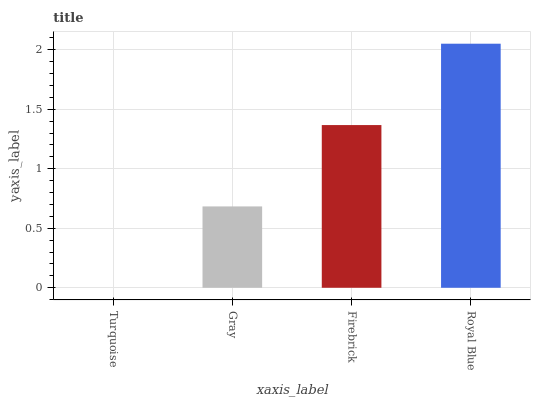Is Turquoise the minimum?
Answer yes or no. Yes. Is Royal Blue the maximum?
Answer yes or no. Yes. Is Gray the minimum?
Answer yes or no. No. Is Gray the maximum?
Answer yes or no. No. Is Gray greater than Turquoise?
Answer yes or no. Yes. Is Turquoise less than Gray?
Answer yes or no. Yes. Is Turquoise greater than Gray?
Answer yes or no. No. Is Gray less than Turquoise?
Answer yes or no. No. Is Firebrick the high median?
Answer yes or no. Yes. Is Gray the low median?
Answer yes or no. Yes. Is Turquoise the high median?
Answer yes or no. No. Is Firebrick the low median?
Answer yes or no. No. 